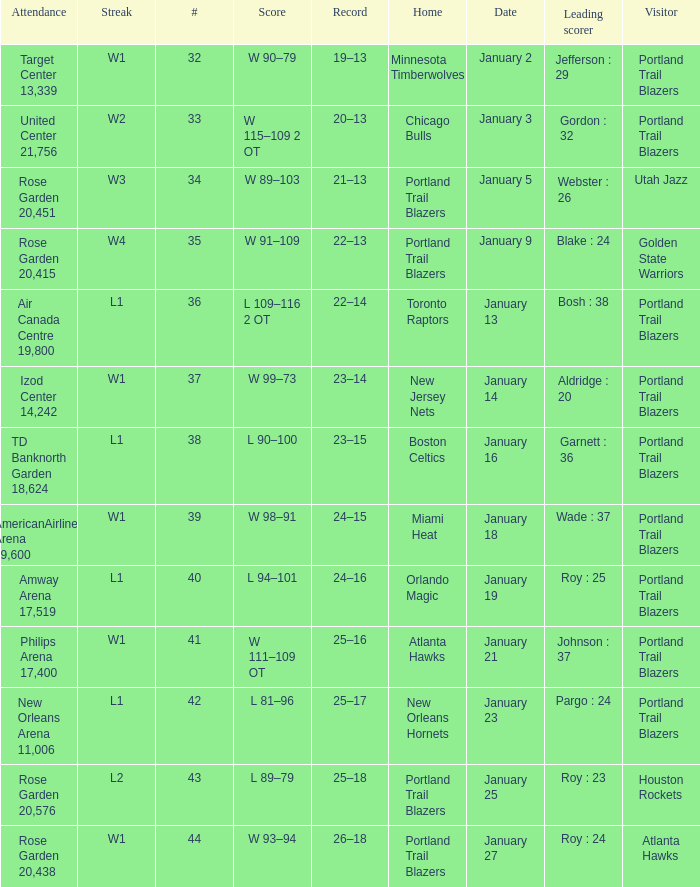What records have a score of l 109–116 2 ot 22–14. 